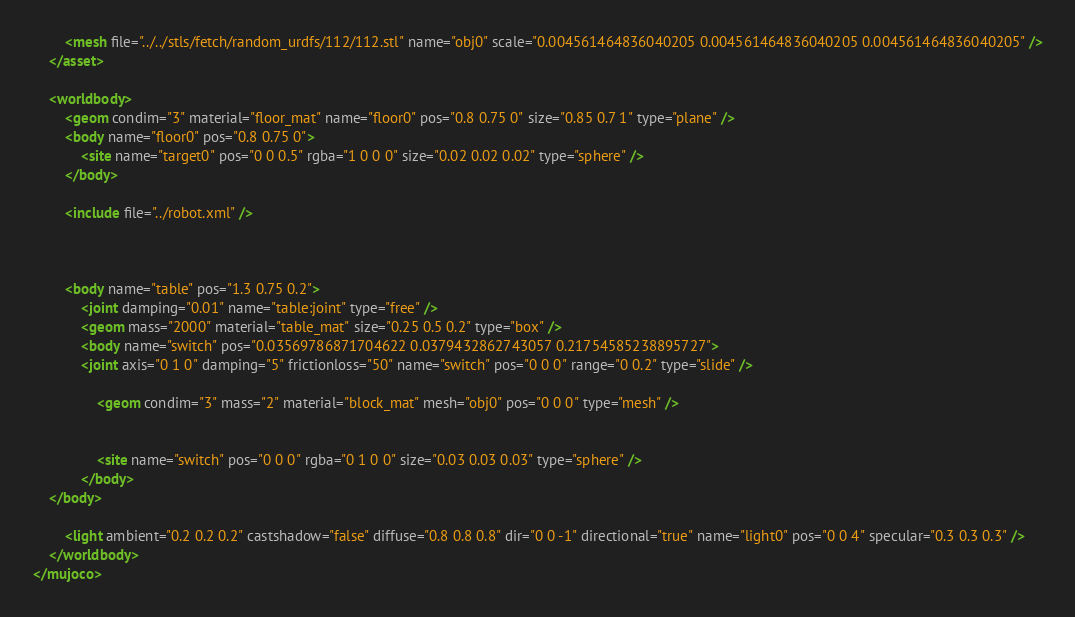<code> <loc_0><loc_0><loc_500><loc_500><_XML_>		<mesh file="../../stls/fetch/random_urdfs/112/112.stl" name="obj0" scale="0.004561464836040205 0.004561464836040205 0.004561464836040205" />
	</asset>

	<worldbody>
		<geom condim="3" material="floor_mat" name="floor0" pos="0.8 0.75 0" size="0.85 0.7 1" type="plane" />
		<body name="floor0" pos="0.8 0.75 0">
			<site name="target0" pos="0 0 0.5" rgba="1 0 0 0" size="0.02 0.02 0.02" type="sphere" />
		</body>

		<include file="../robot.xml" />

		

		<body name="table" pos="1.3 0.75 0.2">
			<joint damping="0.01" name="table:joint" type="free" />
			<geom mass="2000" material="table_mat" size="0.25 0.5 0.2" type="box" />
			<body name="switch" pos="0.03569786871704622 0.0379432862743057 0.21754585238895727">
		    <joint axis="0 1 0" damping="5" frictionloss="50" name="switch" pos="0 0 0" range="0 0.2" type="slide" />
				
				<geom condim="3" mass="2" material="block_mat" mesh="obj0" pos="0 0 0" type="mesh" />
				
				
				<site name="switch" pos="0 0 0" rgba="0 1 0 0" size="0.03 0.03 0.03" type="sphere" />
			</body>
    </body>

		<light ambient="0.2 0.2 0.2" castshadow="false" diffuse="0.8 0.8 0.8" dir="0 0 -1" directional="true" name="light0" pos="0 0 4" specular="0.3 0.3 0.3" />
	</worldbody>
</mujoco></code> 